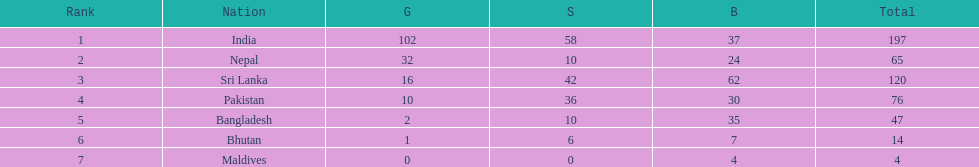How many additional gold medals has nepal won compared to pakistan? 22. 